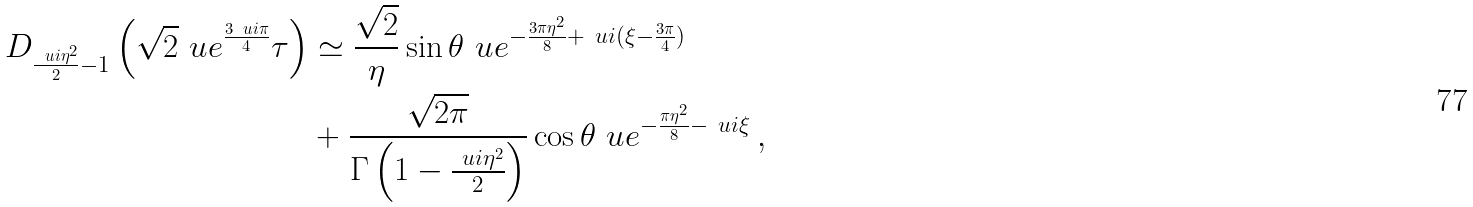<formula> <loc_0><loc_0><loc_500><loc_500>D _ { \frac { \ u i \eta ^ { 2 } } { 2 } - 1 } \left ( \sqrt { 2 } \ u e ^ { \frac { 3 \ u i \pi } { 4 } } \tau \right ) & \simeq \frac { \sqrt { 2 } } { \eta } \sin \theta \ u e ^ { - \frac { 3 \pi \eta ^ { 2 } } { 8 } + \ u i ( \xi - \frac { 3 \pi } { 4 } ) } \\ & + \frac { \sqrt { 2 \pi } } { \Gamma \left ( 1 - \frac { \ u i \eta ^ { 2 } } { 2 } \right ) } \cos \theta \ u e ^ { - \frac { \pi \eta ^ { 2 } } { 8 } - \ u i \xi } \, ,</formula> 